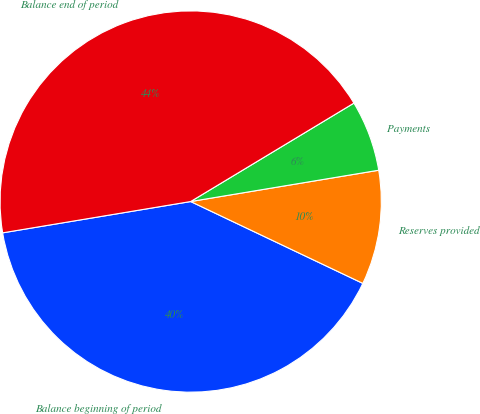<chart> <loc_0><loc_0><loc_500><loc_500><pie_chart><fcel>Balance beginning of period<fcel>Reserves provided<fcel>Payments<fcel>Balance end of period<nl><fcel>40.31%<fcel>9.69%<fcel>6.01%<fcel>43.99%<nl></chart> 